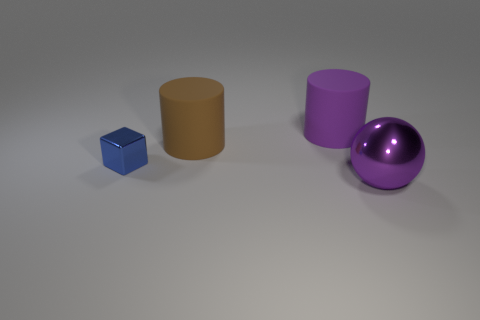There is a big cylinder that is the same color as the big shiny thing; what is it made of?
Give a very brief answer. Rubber. Is there anything else that has the same color as the metallic ball?
Provide a succinct answer. Yes. There is a metallic object in front of the small metal block; what is its color?
Make the answer very short. Purple. Does the large thing that is on the left side of the purple matte thing have the same color as the big sphere?
Provide a succinct answer. No. What is the material of the other object that is the same shape as the brown rubber thing?
Your response must be concise. Rubber. How many things are the same size as the purple metal ball?
Provide a short and direct response. 2. The blue thing is what shape?
Your response must be concise. Cube. There is a object that is both right of the cube and in front of the brown matte cylinder; what is its size?
Your response must be concise. Large. There is a large object behind the large brown matte cylinder; what material is it?
Ensure brevity in your answer.  Rubber. There is a small object; is it the same color as the object in front of the small thing?
Make the answer very short. No. 